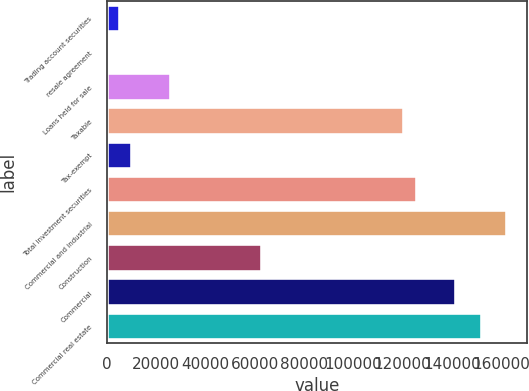<chart> <loc_0><loc_0><loc_500><loc_500><bar_chart><fcel>Trading account securities<fcel>resale agreement<fcel>Loans held for sale<fcel>Taxable<fcel>Tax-exempt<fcel>Total investment securities<fcel>Commercial and industrial<fcel>Construction<fcel>Commercial<fcel>Commercial real estate<nl><fcel>5253<fcel>10<fcel>26225<fcel>120599<fcel>10496<fcel>125842<fcel>162543<fcel>62926<fcel>141571<fcel>152057<nl></chart> 